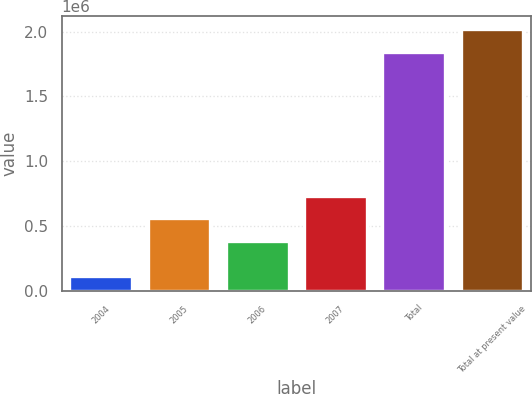Convert chart to OTSL. <chart><loc_0><loc_0><loc_500><loc_500><bar_chart><fcel>2004<fcel>2005<fcel>2006<fcel>2007<fcel>Total<fcel>Total at present value<nl><fcel>109587<fcel>557010<fcel>383270<fcel>730749<fcel>1.84698e+06<fcel>2.02072e+06<nl></chart> 